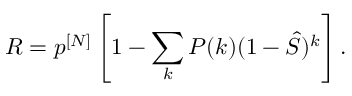<formula> <loc_0><loc_0><loc_500><loc_500>R = p ^ { [ N ] } \left [ 1 - \sum _ { k } P ( k ) ( 1 - \hat { S } ) ^ { k } \right ] .</formula> 